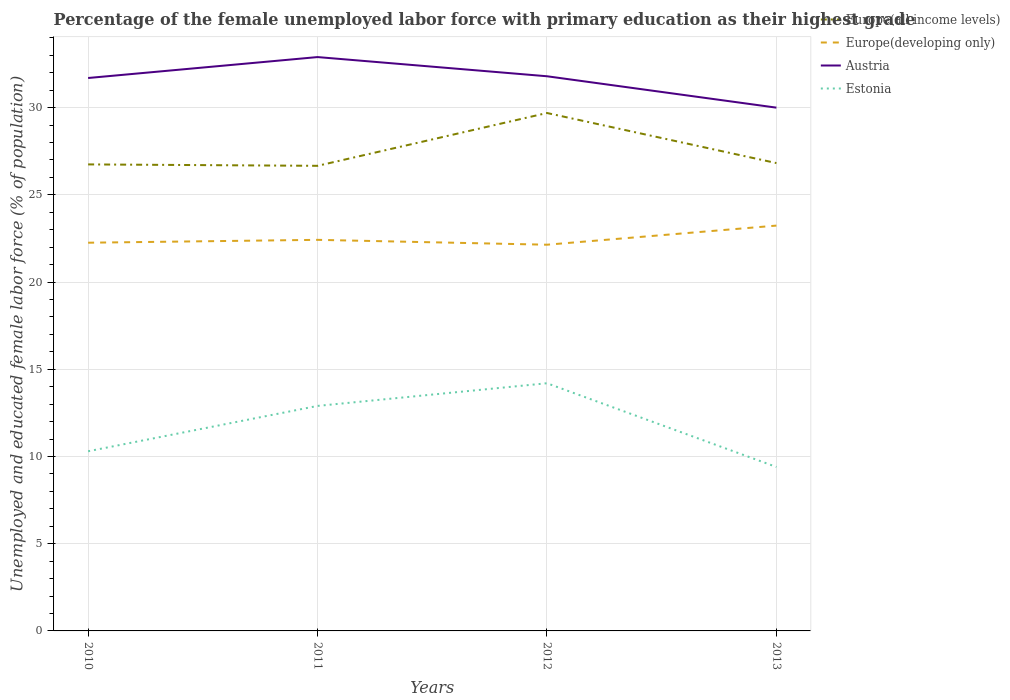How many different coloured lines are there?
Offer a terse response. 4. Does the line corresponding to Estonia intersect with the line corresponding to Austria?
Offer a terse response. No. Across all years, what is the maximum percentage of the unemployed female labor force with primary education in Europe(developing only)?
Your answer should be very brief. 22.14. In which year was the percentage of the unemployed female labor force with primary education in Europe(all income levels) maximum?
Offer a very short reply. 2011. What is the total percentage of the unemployed female labor force with primary education in Europe(all income levels) in the graph?
Give a very brief answer. -0.08. What is the difference between the highest and the second highest percentage of the unemployed female labor force with primary education in Europe(all income levels)?
Make the answer very short. 3.03. Is the percentage of the unemployed female labor force with primary education in Estonia strictly greater than the percentage of the unemployed female labor force with primary education in Austria over the years?
Offer a terse response. Yes. How many lines are there?
Ensure brevity in your answer.  4. How many legend labels are there?
Your answer should be very brief. 4. What is the title of the graph?
Give a very brief answer. Percentage of the female unemployed labor force with primary education as their highest grade. What is the label or title of the Y-axis?
Provide a short and direct response. Unemployed and educated female labor force (% of population). What is the Unemployed and educated female labor force (% of population) in Europe(all income levels) in 2010?
Your response must be concise. 26.75. What is the Unemployed and educated female labor force (% of population) of Europe(developing only) in 2010?
Your response must be concise. 22.26. What is the Unemployed and educated female labor force (% of population) in Austria in 2010?
Provide a succinct answer. 31.7. What is the Unemployed and educated female labor force (% of population) in Estonia in 2010?
Give a very brief answer. 10.3. What is the Unemployed and educated female labor force (% of population) in Europe(all income levels) in 2011?
Provide a short and direct response. 26.67. What is the Unemployed and educated female labor force (% of population) of Europe(developing only) in 2011?
Your answer should be compact. 22.42. What is the Unemployed and educated female labor force (% of population) in Austria in 2011?
Keep it short and to the point. 32.9. What is the Unemployed and educated female labor force (% of population) of Estonia in 2011?
Ensure brevity in your answer.  12.9. What is the Unemployed and educated female labor force (% of population) of Europe(all income levels) in 2012?
Keep it short and to the point. 29.69. What is the Unemployed and educated female labor force (% of population) of Europe(developing only) in 2012?
Make the answer very short. 22.14. What is the Unemployed and educated female labor force (% of population) in Austria in 2012?
Offer a very short reply. 31.8. What is the Unemployed and educated female labor force (% of population) of Estonia in 2012?
Make the answer very short. 14.2. What is the Unemployed and educated female labor force (% of population) of Europe(all income levels) in 2013?
Make the answer very short. 26.82. What is the Unemployed and educated female labor force (% of population) in Europe(developing only) in 2013?
Give a very brief answer. 23.24. What is the Unemployed and educated female labor force (% of population) of Austria in 2013?
Keep it short and to the point. 30. What is the Unemployed and educated female labor force (% of population) in Estonia in 2013?
Offer a terse response. 9.4. Across all years, what is the maximum Unemployed and educated female labor force (% of population) in Europe(all income levels)?
Make the answer very short. 29.69. Across all years, what is the maximum Unemployed and educated female labor force (% of population) of Europe(developing only)?
Make the answer very short. 23.24. Across all years, what is the maximum Unemployed and educated female labor force (% of population) of Austria?
Give a very brief answer. 32.9. Across all years, what is the maximum Unemployed and educated female labor force (% of population) in Estonia?
Offer a very short reply. 14.2. Across all years, what is the minimum Unemployed and educated female labor force (% of population) in Europe(all income levels)?
Your answer should be compact. 26.67. Across all years, what is the minimum Unemployed and educated female labor force (% of population) in Europe(developing only)?
Your answer should be compact. 22.14. Across all years, what is the minimum Unemployed and educated female labor force (% of population) in Estonia?
Make the answer very short. 9.4. What is the total Unemployed and educated female labor force (% of population) in Europe(all income levels) in the graph?
Provide a succinct answer. 109.93. What is the total Unemployed and educated female labor force (% of population) in Europe(developing only) in the graph?
Provide a short and direct response. 90.06. What is the total Unemployed and educated female labor force (% of population) of Austria in the graph?
Provide a short and direct response. 126.4. What is the total Unemployed and educated female labor force (% of population) of Estonia in the graph?
Your answer should be compact. 46.8. What is the difference between the Unemployed and educated female labor force (% of population) in Europe(all income levels) in 2010 and that in 2011?
Offer a very short reply. 0.08. What is the difference between the Unemployed and educated female labor force (% of population) of Europe(developing only) in 2010 and that in 2011?
Your answer should be very brief. -0.16. What is the difference between the Unemployed and educated female labor force (% of population) of Estonia in 2010 and that in 2011?
Offer a very short reply. -2.6. What is the difference between the Unemployed and educated female labor force (% of population) in Europe(all income levels) in 2010 and that in 2012?
Provide a short and direct response. -2.95. What is the difference between the Unemployed and educated female labor force (% of population) in Europe(developing only) in 2010 and that in 2012?
Keep it short and to the point. 0.11. What is the difference between the Unemployed and educated female labor force (% of population) in Europe(all income levels) in 2010 and that in 2013?
Provide a succinct answer. -0.08. What is the difference between the Unemployed and educated female labor force (% of population) in Europe(developing only) in 2010 and that in 2013?
Make the answer very short. -0.98. What is the difference between the Unemployed and educated female labor force (% of population) of Europe(all income levels) in 2011 and that in 2012?
Make the answer very short. -3.03. What is the difference between the Unemployed and educated female labor force (% of population) of Europe(developing only) in 2011 and that in 2012?
Ensure brevity in your answer.  0.28. What is the difference between the Unemployed and educated female labor force (% of population) in Austria in 2011 and that in 2012?
Keep it short and to the point. 1.1. What is the difference between the Unemployed and educated female labor force (% of population) in Europe(all income levels) in 2011 and that in 2013?
Offer a terse response. -0.16. What is the difference between the Unemployed and educated female labor force (% of population) in Europe(developing only) in 2011 and that in 2013?
Give a very brief answer. -0.82. What is the difference between the Unemployed and educated female labor force (% of population) of Austria in 2011 and that in 2013?
Provide a succinct answer. 2.9. What is the difference between the Unemployed and educated female labor force (% of population) of Europe(all income levels) in 2012 and that in 2013?
Make the answer very short. 2.87. What is the difference between the Unemployed and educated female labor force (% of population) of Europe(developing only) in 2012 and that in 2013?
Your response must be concise. -1.1. What is the difference between the Unemployed and educated female labor force (% of population) in Estonia in 2012 and that in 2013?
Offer a very short reply. 4.8. What is the difference between the Unemployed and educated female labor force (% of population) in Europe(all income levels) in 2010 and the Unemployed and educated female labor force (% of population) in Europe(developing only) in 2011?
Give a very brief answer. 4.32. What is the difference between the Unemployed and educated female labor force (% of population) of Europe(all income levels) in 2010 and the Unemployed and educated female labor force (% of population) of Austria in 2011?
Your answer should be very brief. -6.15. What is the difference between the Unemployed and educated female labor force (% of population) of Europe(all income levels) in 2010 and the Unemployed and educated female labor force (% of population) of Estonia in 2011?
Keep it short and to the point. 13.85. What is the difference between the Unemployed and educated female labor force (% of population) in Europe(developing only) in 2010 and the Unemployed and educated female labor force (% of population) in Austria in 2011?
Offer a terse response. -10.64. What is the difference between the Unemployed and educated female labor force (% of population) of Europe(developing only) in 2010 and the Unemployed and educated female labor force (% of population) of Estonia in 2011?
Provide a short and direct response. 9.36. What is the difference between the Unemployed and educated female labor force (% of population) in Europe(all income levels) in 2010 and the Unemployed and educated female labor force (% of population) in Europe(developing only) in 2012?
Your answer should be very brief. 4.6. What is the difference between the Unemployed and educated female labor force (% of population) of Europe(all income levels) in 2010 and the Unemployed and educated female labor force (% of population) of Austria in 2012?
Your answer should be compact. -5.05. What is the difference between the Unemployed and educated female labor force (% of population) in Europe(all income levels) in 2010 and the Unemployed and educated female labor force (% of population) in Estonia in 2012?
Give a very brief answer. 12.55. What is the difference between the Unemployed and educated female labor force (% of population) of Europe(developing only) in 2010 and the Unemployed and educated female labor force (% of population) of Austria in 2012?
Make the answer very short. -9.54. What is the difference between the Unemployed and educated female labor force (% of population) in Europe(developing only) in 2010 and the Unemployed and educated female labor force (% of population) in Estonia in 2012?
Your answer should be compact. 8.06. What is the difference between the Unemployed and educated female labor force (% of population) in Europe(all income levels) in 2010 and the Unemployed and educated female labor force (% of population) in Europe(developing only) in 2013?
Keep it short and to the point. 3.51. What is the difference between the Unemployed and educated female labor force (% of population) of Europe(all income levels) in 2010 and the Unemployed and educated female labor force (% of population) of Austria in 2013?
Provide a succinct answer. -3.25. What is the difference between the Unemployed and educated female labor force (% of population) in Europe(all income levels) in 2010 and the Unemployed and educated female labor force (% of population) in Estonia in 2013?
Provide a succinct answer. 17.35. What is the difference between the Unemployed and educated female labor force (% of population) of Europe(developing only) in 2010 and the Unemployed and educated female labor force (% of population) of Austria in 2013?
Provide a succinct answer. -7.74. What is the difference between the Unemployed and educated female labor force (% of population) of Europe(developing only) in 2010 and the Unemployed and educated female labor force (% of population) of Estonia in 2013?
Offer a terse response. 12.86. What is the difference between the Unemployed and educated female labor force (% of population) of Austria in 2010 and the Unemployed and educated female labor force (% of population) of Estonia in 2013?
Your answer should be compact. 22.3. What is the difference between the Unemployed and educated female labor force (% of population) in Europe(all income levels) in 2011 and the Unemployed and educated female labor force (% of population) in Europe(developing only) in 2012?
Provide a short and direct response. 4.52. What is the difference between the Unemployed and educated female labor force (% of population) of Europe(all income levels) in 2011 and the Unemployed and educated female labor force (% of population) of Austria in 2012?
Your answer should be very brief. -5.13. What is the difference between the Unemployed and educated female labor force (% of population) of Europe(all income levels) in 2011 and the Unemployed and educated female labor force (% of population) of Estonia in 2012?
Keep it short and to the point. 12.47. What is the difference between the Unemployed and educated female labor force (% of population) in Europe(developing only) in 2011 and the Unemployed and educated female labor force (% of population) in Austria in 2012?
Provide a succinct answer. -9.38. What is the difference between the Unemployed and educated female labor force (% of population) of Europe(developing only) in 2011 and the Unemployed and educated female labor force (% of population) of Estonia in 2012?
Offer a very short reply. 8.22. What is the difference between the Unemployed and educated female labor force (% of population) in Europe(all income levels) in 2011 and the Unemployed and educated female labor force (% of population) in Europe(developing only) in 2013?
Offer a terse response. 3.43. What is the difference between the Unemployed and educated female labor force (% of population) of Europe(all income levels) in 2011 and the Unemployed and educated female labor force (% of population) of Austria in 2013?
Keep it short and to the point. -3.33. What is the difference between the Unemployed and educated female labor force (% of population) in Europe(all income levels) in 2011 and the Unemployed and educated female labor force (% of population) in Estonia in 2013?
Your response must be concise. 17.27. What is the difference between the Unemployed and educated female labor force (% of population) of Europe(developing only) in 2011 and the Unemployed and educated female labor force (% of population) of Austria in 2013?
Give a very brief answer. -7.58. What is the difference between the Unemployed and educated female labor force (% of population) in Europe(developing only) in 2011 and the Unemployed and educated female labor force (% of population) in Estonia in 2013?
Your answer should be very brief. 13.02. What is the difference between the Unemployed and educated female labor force (% of population) of Europe(all income levels) in 2012 and the Unemployed and educated female labor force (% of population) of Europe(developing only) in 2013?
Ensure brevity in your answer.  6.46. What is the difference between the Unemployed and educated female labor force (% of population) in Europe(all income levels) in 2012 and the Unemployed and educated female labor force (% of population) in Austria in 2013?
Give a very brief answer. -0.31. What is the difference between the Unemployed and educated female labor force (% of population) of Europe(all income levels) in 2012 and the Unemployed and educated female labor force (% of population) of Estonia in 2013?
Provide a short and direct response. 20.29. What is the difference between the Unemployed and educated female labor force (% of population) in Europe(developing only) in 2012 and the Unemployed and educated female labor force (% of population) in Austria in 2013?
Offer a terse response. -7.86. What is the difference between the Unemployed and educated female labor force (% of population) of Europe(developing only) in 2012 and the Unemployed and educated female labor force (% of population) of Estonia in 2013?
Your response must be concise. 12.74. What is the difference between the Unemployed and educated female labor force (% of population) of Austria in 2012 and the Unemployed and educated female labor force (% of population) of Estonia in 2013?
Your answer should be compact. 22.4. What is the average Unemployed and educated female labor force (% of population) of Europe(all income levels) per year?
Your response must be concise. 27.48. What is the average Unemployed and educated female labor force (% of population) in Europe(developing only) per year?
Your answer should be compact. 22.51. What is the average Unemployed and educated female labor force (% of population) in Austria per year?
Ensure brevity in your answer.  31.6. In the year 2010, what is the difference between the Unemployed and educated female labor force (% of population) of Europe(all income levels) and Unemployed and educated female labor force (% of population) of Europe(developing only)?
Provide a short and direct response. 4.49. In the year 2010, what is the difference between the Unemployed and educated female labor force (% of population) in Europe(all income levels) and Unemployed and educated female labor force (% of population) in Austria?
Offer a very short reply. -4.95. In the year 2010, what is the difference between the Unemployed and educated female labor force (% of population) in Europe(all income levels) and Unemployed and educated female labor force (% of population) in Estonia?
Keep it short and to the point. 16.45. In the year 2010, what is the difference between the Unemployed and educated female labor force (% of population) in Europe(developing only) and Unemployed and educated female labor force (% of population) in Austria?
Keep it short and to the point. -9.44. In the year 2010, what is the difference between the Unemployed and educated female labor force (% of population) of Europe(developing only) and Unemployed and educated female labor force (% of population) of Estonia?
Offer a terse response. 11.96. In the year 2010, what is the difference between the Unemployed and educated female labor force (% of population) in Austria and Unemployed and educated female labor force (% of population) in Estonia?
Your response must be concise. 21.4. In the year 2011, what is the difference between the Unemployed and educated female labor force (% of population) of Europe(all income levels) and Unemployed and educated female labor force (% of population) of Europe(developing only)?
Ensure brevity in your answer.  4.24. In the year 2011, what is the difference between the Unemployed and educated female labor force (% of population) of Europe(all income levels) and Unemployed and educated female labor force (% of population) of Austria?
Ensure brevity in your answer.  -6.23. In the year 2011, what is the difference between the Unemployed and educated female labor force (% of population) in Europe(all income levels) and Unemployed and educated female labor force (% of population) in Estonia?
Provide a succinct answer. 13.77. In the year 2011, what is the difference between the Unemployed and educated female labor force (% of population) in Europe(developing only) and Unemployed and educated female labor force (% of population) in Austria?
Your answer should be compact. -10.48. In the year 2011, what is the difference between the Unemployed and educated female labor force (% of population) in Europe(developing only) and Unemployed and educated female labor force (% of population) in Estonia?
Your answer should be very brief. 9.52. In the year 2011, what is the difference between the Unemployed and educated female labor force (% of population) in Austria and Unemployed and educated female labor force (% of population) in Estonia?
Ensure brevity in your answer.  20. In the year 2012, what is the difference between the Unemployed and educated female labor force (% of population) in Europe(all income levels) and Unemployed and educated female labor force (% of population) in Europe(developing only)?
Your answer should be compact. 7.55. In the year 2012, what is the difference between the Unemployed and educated female labor force (% of population) of Europe(all income levels) and Unemployed and educated female labor force (% of population) of Austria?
Make the answer very short. -2.11. In the year 2012, what is the difference between the Unemployed and educated female labor force (% of population) in Europe(all income levels) and Unemployed and educated female labor force (% of population) in Estonia?
Provide a succinct answer. 15.49. In the year 2012, what is the difference between the Unemployed and educated female labor force (% of population) in Europe(developing only) and Unemployed and educated female labor force (% of population) in Austria?
Your answer should be compact. -9.66. In the year 2012, what is the difference between the Unemployed and educated female labor force (% of population) of Europe(developing only) and Unemployed and educated female labor force (% of population) of Estonia?
Provide a succinct answer. 7.94. In the year 2012, what is the difference between the Unemployed and educated female labor force (% of population) in Austria and Unemployed and educated female labor force (% of population) in Estonia?
Make the answer very short. 17.6. In the year 2013, what is the difference between the Unemployed and educated female labor force (% of population) in Europe(all income levels) and Unemployed and educated female labor force (% of population) in Europe(developing only)?
Make the answer very short. 3.58. In the year 2013, what is the difference between the Unemployed and educated female labor force (% of population) in Europe(all income levels) and Unemployed and educated female labor force (% of population) in Austria?
Your response must be concise. -3.18. In the year 2013, what is the difference between the Unemployed and educated female labor force (% of population) in Europe(all income levels) and Unemployed and educated female labor force (% of population) in Estonia?
Provide a succinct answer. 17.42. In the year 2013, what is the difference between the Unemployed and educated female labor force (% of population) in Europe(developing only) and Unemployed and educated female labor force (% of population) in Austria?
Offer a very short reply. -6.76. In the year 2013, what is the difference between the Unemployed and educated female labor force (% of population) of Europe(developing only) and Unemployed and educated female labor force (% of population) of Estonia?
Ensure brevity in your answer.  13.84. In the year 2013, what is the difference between the Unemployed and educated female labor force (% of population) of Austria and Unemployed and educated female labor force (% of population) of Estonia?
Your answer should be very brief. 20.6. What is the ratio of the Unemployed and educated female labor force (% of population) of Europe(developing only) in 2010 to that in 2011?
Provide a succinct answer. 0.99. What is the ratio of the Unemployed and educated female labor force (% of population) in Austria in 2010 to that in 2011?
Offer a very short reply. 0.96. What is the ratio of the Unemployed and educated female labor force (% of population) of Estonia in 2010 to that in 2011?
Give a very brief answer. 0.8. What is the ratio of the Unemployed and educated female labor force (% of population) of Europe(all income levels) in 2010 to that in 2012?
Give a very brief answer. 0.9. What is the ratio of the Unemployed and educated female labor force (% of population) in Estonia in 2010 to that in 2012?
Ensure brevity in your answer.  0.73. What is the ratio of the Unemployed and educated female labor force (% of population) in Europe(developing only) in 2010 to that in 2013?
Offer a terse response. 0.96. What is the ratio of the Unemployed and educated female labor force (% of population) of Austria in 2010 to that in 2013?
Provide a short and direct response. 1.06. What is the ratio of the Unemployed and educated female labor force (% of population) of Estonia in 2010 to that in 2013?
Offer a terse response. 1.1. What is the ratio of the Unemployed and educated female labor force (% of population) of Europe(all income levels) in 2011 to that in 2012?
Your response must be concise. 0.9. What is the ratio of the Unemployed and educated female labor force (% of population) in Europe(developing only) in 2011 to that in 2012?
Your answer should be compact. 1.01. What is the ratio of the Unemployed and educated female labor force (% of population) in Austria in 2011 to that in 2012?
Give a very brief answer. 1.03. What is the ratio of the Unemployed and educated female labor force (% of population) in Estonia in 2011 to that in 2012?
Keep it short and to the point. 0.91. What is the ratio of the Unemployed and educated female labor force (% of population) in Europe(developing only) in 2011 to that in 2013?
Keep it short and to the point. 0.96. What is the ratio of the Unemployed and educated female labor force (% of population) in Austria in 2011 to that in 2013?
Provide a succinct answer. 1.1. What is the ratio of the Unemployed and educated female labor force (% of population) in Estonia in 2011 to that in 2013?
Offer a very short reply. 1.37. What is the ratio of the Unemployed and educated female labor force (% of population) of Europe(all income levels) in 2012 to that in 2013?
Your answer should be compact. 1.11. What is the ratio of the Unemployed and educated female labor force (% of population) of Europe(developing only) in 2012 to that in 2013?
Your response must be concise. 0.95. What is the ratio of the Unemployed and educated female labor force (% of population) of Austria in 2012 to that in 2013?
Provide a succinct answer. 1.06. What is the ratio of the Unemployed and educated female labor force (% of population) in Estonia in 2012 to that in 2013?
Keep it short and to the point. 1.51. What is the difference between the highest and the second highest Unemployed and educated female labor force (% of population) of Europe(all income levels)?
Offer a very short reply. 2.87. What is the difference between the highest and the second highest Unemployed and educated female labor force (% of population) in Europe(developing only)?
Make the answer very short. 0.82. What is the difference between the highest and the second highest Unemployed and educated female labor force (% of population) in Estonia?
Your answer should be compact. 1.3. What is the difference between the highest and the lowest Unemployed and educated female labor force (% of population) of Europe(all income levels)?
Provide a succinct answer. 3.03. What is the difference between the highest and the lowest Unemployed and educated female labor force (% of population) in Europe(developing only)?
Keep it short and to the point. 1.1. What is the difference between the highest and the lowest Unemployed and educated female labor force (% of population) of Austria?
Give a very brief answer. 2.9. 